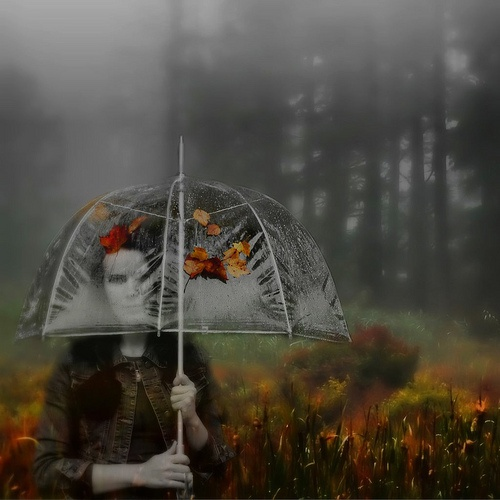Describe the objects in this image and their specific colors. I can see umbrella in darkgray, gray, and black tones and people in darkgray, black, gray, darkgreen, and maroon tones in this image. 